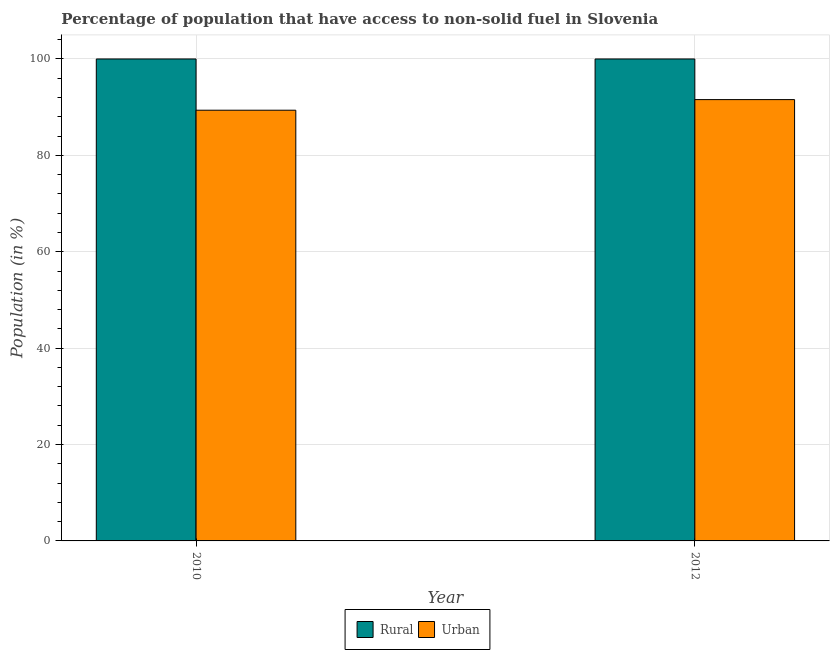How many bars are there on the 1st tick from the left?
Ensure brevity in your answer.  2. How many bars are there on the 2nd tick from the right?
Ensure brevity in your answer.  2. What is the label of the 1st group of bars from the left?
Offer a very short reply. 2010. In how many cases, is the number of bars for a given year not equal to the number of legend labels?
Provide a succinct answer. 0. What is the urban population in 2012?
Your answer should be very brief. 91.57. Across all years, what is the maximum urban population?
Provide a succinct answer. 91.57. Across all years, what is the minimum urban population?
Provide a short and direct response. 89.37. In which year was the rural population maximum?
Your response must be concise. 2010. In which year was the urban population minimum?
Offer a very short reply. 2010. What is the total urban population in the graph?
Your answer should be compact. 180.94. What is the difference between the rural population in 2010 and that in 2012?
Your response must be concise. 0. What is the difference between the rural population in 2012 and the urban population in 2010?
Your answer should be very brief. 0. What is the average rural population per year?
Make the answer very short. 100. In the year 2010, what is the difference between the rural population and urban population?
Offer a very short reply. 0. In how many years, is the urban population greater than 4 %?
Make the answer very short. 2. What is the ratio of the rural population in 2010 to that in 2012?
Give a very brief answer. 1. Is the rural population in 2010 less than that in 2012?
Ensure brevity in your answer.  No. What does the 2nd bar from the left in 2012 represents?
Provide a succinct answer. Urban. What does the 1st bar from the right in 2010 represents?
Give a very brief answer. Urban. How many bars are there?
Offer a very short reply. 4. Are all the bars in the graph horizontal?
Offer a terse response. No. Where does the legend appear in the graph?
Provide a succinct answer. Bottom center. How are the legend labels stacked?
Your answer should be very brief. Horizontal. What is the title of the graph?
Keep it short and to the point. Percentage of population that have access to non-solid fuel in Slovenia. Does "GDP per capita" appear as one of the legend labels in the graph?
Ensure brevity in your answer.  No. What is the label or title of the X-axis?
Your answer should be very brief. Year. What is the Population (in %) in Urban in 2010?
Your answer should be compact. 89.37. What is the Population (in %) in Rural in 2012?
Provide a succinct answer. 100. What is the Population (in %) of Urban in 2012?
Provide a succinct answer. 91.57. Across all years, what is the maximum Population (in %) in Urban?
Provide a short and direct response. 91.57. Across all years, what is the minimum Population (in %) of Rural?
Keep it short and to the point. 100. Across all years, what is the minimum Population (in %) of Urban?
Keep it short and to the point. 89.37. What is the total Population (in %) in Urban in the graph?
Ensure brevity in your answer.  180.94. What is the difference between the Population (in %) of Rural in 2010 and that in 2012?
Provide a succinct answer. 0. What is the difference between the Population (in %) in Urban in 2010 and that in 2012?
Provide a succinct answer. -2.2. What is the difference between the Population (in %) in Rural in 2010 and the Population (in %) in Urban in 2012?
Make the answer very short. 8.43. What is the average Population (in %) in Urban per year?
Your answer should be compact. 90.47. In the year 2010, what is the difference between the Population (in %) in Rural and Population (in %) in Urban?
Your response must be concise. 10.63. In the year 2012, what is the difference between the Population (in %) in Rural and Population (in %) in Urban?
Ensure brevity in your answer.  8.43. What is the ratio of the Population (in %) of Rural in 2010 to that in 2012?
Your response must be concise. 1. What is the ratio of the Population (in %) of Urban in 2010 to that in 2012?
Keep it short and to the point. 0.98. What is the difference between the highest and the second highest Population (in %) of Urban?
Provide a short and direct response. 2.2. What is the difference between the highest and the lowest Population (in %) in Urban?
Your answer should be compact. 2.2. 